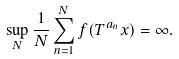<formula> <loc_0><loc_0><loc_500><loc_500>\sup _ { N } \frac { 1 } { N } \sum _ { n = 1 } ^ { N } f ( T ^ { a _ { n } } x ) = \infty .</formula> 